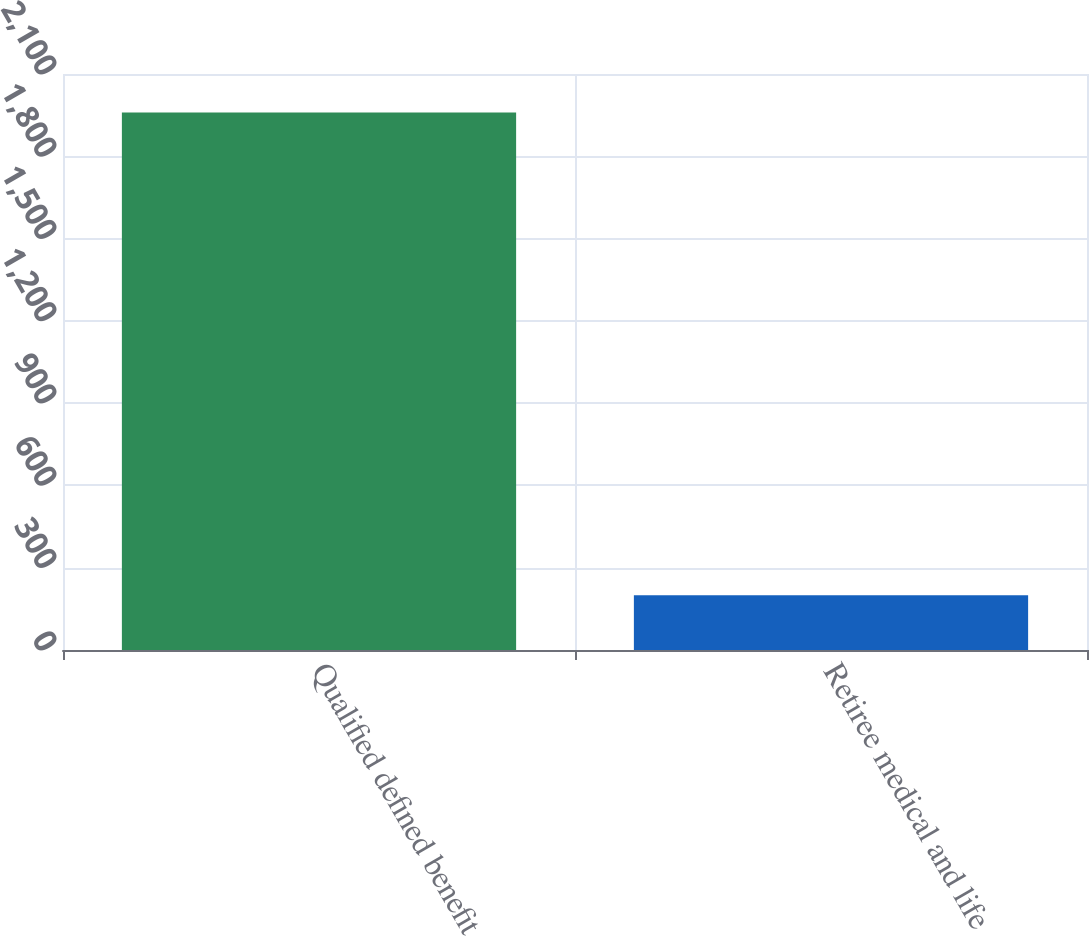Convert chart to OTSL. <chart><loc_0><loc_0><loc_500><loc_500><bar_chart><fcel>Qualified defined benefit<fcel>Retiree medical and life<nl><fcel>1960<fcel>200<nl></chart> 